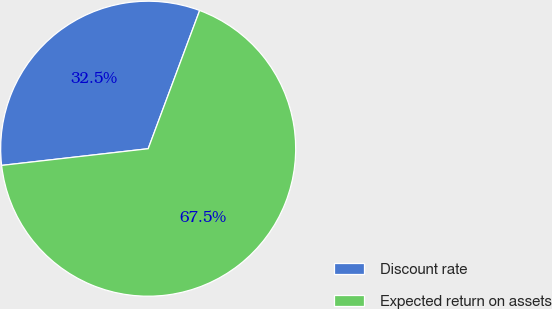Convert chart. <chart><loc_0><loc_0><loc_500><loc_500><pie_chart><fcel>Discount rate<fcel>Expected return on assets<nl><fcel>32.48%<fcel>67.52%<nl></chart> 